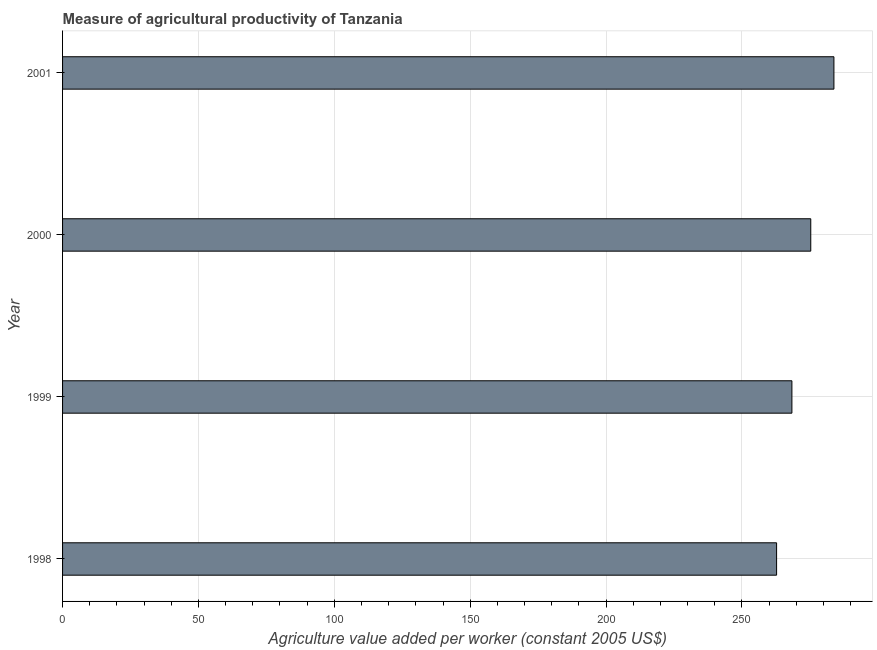What is the title of the graph?
Provide a succinct answer. Measure of agricultural productivity of Tanzania. What is the label or title of the X-axis?
Give a very brief answer. Agriculture value added per worker (constant 2005 US$). What is the label or title of the Y-axis?
Provide a succinct answer. Year. What is the agriculture value added per worker in 1999?
Your answer should be very brief. 268.38. Across all years, what is the maximum agriculture value added per worker?
Provide a short and direct response. 283.84. Across all years, what is the minimum agriculture value added per worker?
Offer a very short reply. 262.75. What is the sum of the agriculture value added per worker?
Keep it short and to the point. 1090.29. What is the difference between the agriculture value added per worker in 1998 and 2001?
Your answer should be very brief. -21.09. What is the average agriculture value added per worker per year?
Provide a succinct answer. 272.57. What is the median agriculture value added per worker?
Your response must be concise. 271.85. What is the ratio of the agriculture value added per worker in 1998 to that in 2001?
Provide a short and direct response. 0.93. Is the agriculture value added per worker in 1998 less than that in 2000?
Provide a succinct answer. Yes. Is the difference between the agriculture value added per worker in 1998 and 1999 greater than the difference between any two years?
Ensure brevity in your answer.  No. What is the difference between the highest and the second highest agriculture value added per worker?
Your answer should be very brief. 8.52. What is the difference between the highest and the lowest agriculture value added per worker?
Your answer should be compact. 21.09. In how many years, is the agriculture value added per worker greater than the average agriculture value added per worker taken over all years?
Keep it short and to the point. 2. How many bars are there?
Your response must be concise. 4. How many years are there in the graph?
Provide a short and direct response. 4. Are the values on the major ticks of X-axis written in scientific E-notation?
Provide a short and direct response. No. What is the Agriculture value added per worker (constant 2005 US$) in 1998?
Provide a short and direct response. 262.75. What is the Agriculture value added per worker (constant 2005 US$) of 1999?
Provide a short and direct response. 268.38. What is the Agriculture value added per worker (constant 2005 US$) in 2000?
Make the answer very short. 275.32. What is the Agriculture value added per worker (constant 2005 US$) of 2001?
Ensure brevity in your answer.  283.84. What is the difference between the Agriculture value added per worker (constant 2005 US$) in 1998 and 1999?
Give a very brief answer. -5.63. What is the difference between the Agriculture value added per worker (constant 2005 US$) in 1998 and 2000?
Give a very brief answer. -12.57. What is the difference between the Agriculture value added per worker (constant 2005 US$) in 1998 and 2001?
Offer a very short reply. -21.09. What is the difference between the Agriculture value added per worker (constant 2005 US$) in 1999 and 2000?
Keep it short and to the point. -6.94. What is the difference between the Agriculture value added per worker (constant 2005 US$) in 1999 and 2001?
Provide a short and direct response. -15.46. What is the difference between the Agriculture value added per worker (constant 2005 US$) in 2000 and 2001?
Give a very brief answer. -8.52. What is the ratio of the Agriculture value added per worker (constant 2005 US$) in 1998 to that in 2000?
Ensure brevity in your answer.  0.95. What is the ratio of the Agriculture value added per worker (constant 2005 US$) in 1998 to that in 2001?
Your answer should be very brief. 0.93. What is the ratio of the Agriculture value added per worker (constant 2005 US$) in 1999 to that in 2000?
Keep it short and to the point. 0.97. What is the ratio of the Agriculture value added per worker (constant 2005 US$) in 1999 to that in 2001?
Provide a succinct answer. 0.95. 